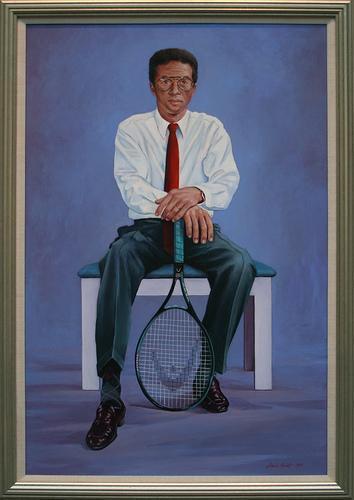How many fingers are shown?
Give a very brief answer. 9. 